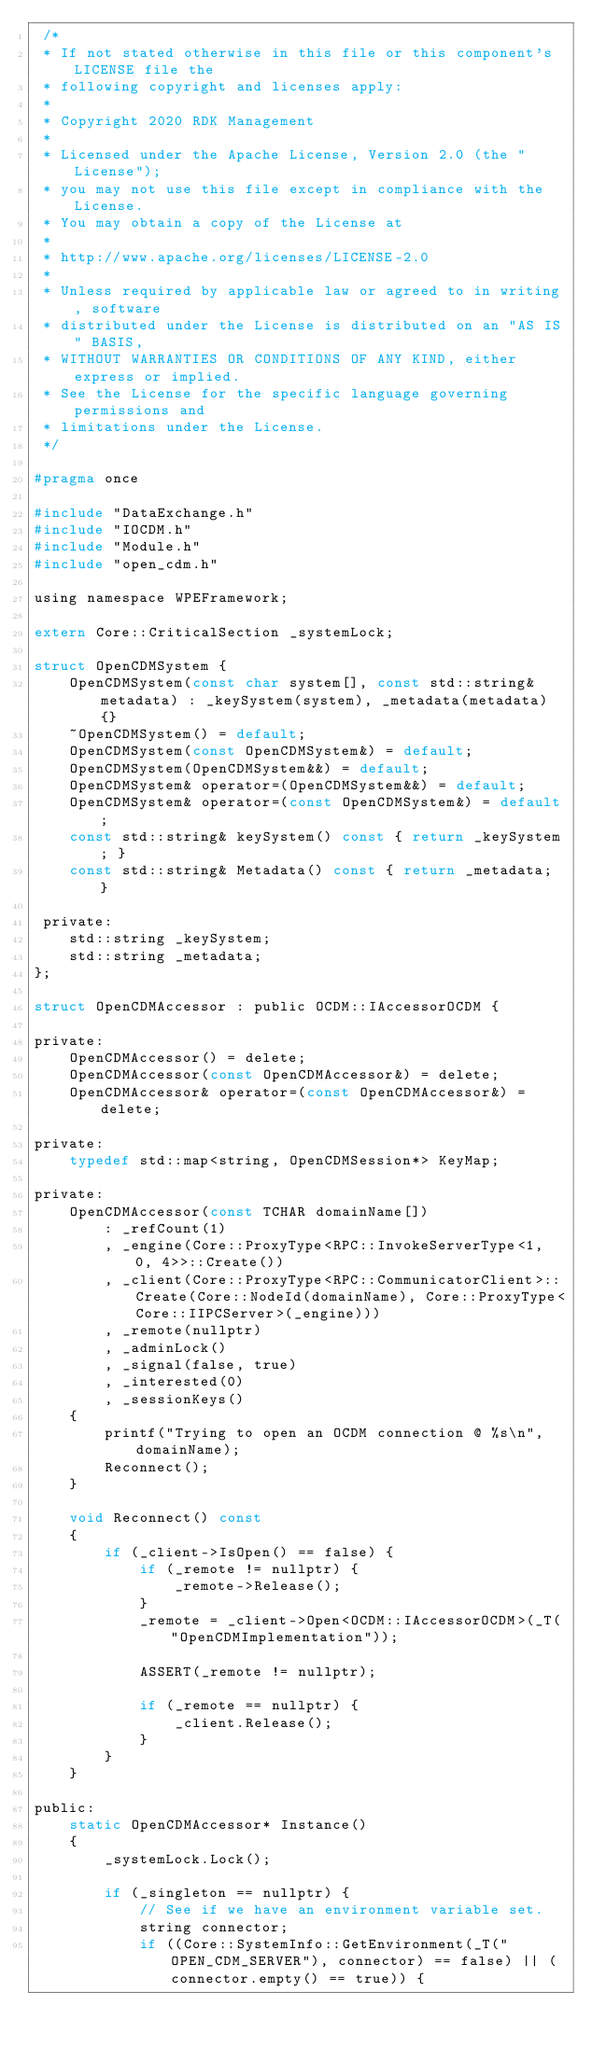<code> <loc_0><loc_0><loc_500><loc_500><_C_> /*
 * If not stated otherwise in this file or this component's LICENSE file the
 * following copyright and licenses apply:
 *
 * Copyright 2020 RDK Management
 *
 * Licensed under the Apache License, Version 2.0 (the "License");
 * you may not use this file except in compliance with the License.
 * You may obtain a copy of the License at
 *
 * http://www.apache.org/licenses/LICENSE-2.0
 *
 * Unless required by applicable law or agreed to in writing, software
 * distributed under the License is distributed on an "AS IS" BASIS,
 * WITHOUT WARRANTIES OR CONDITIONS OF ANY KIND, either express or implied.
 * See the License for the specific language governing permissions and
 * limitations under the License.
 */
 
#pragma once

#include "DataExchange.h"
#include "IOCDM.h"
#include "Module.h"
#include "open_cdm.h"

using namespace WPEFramework;

extern Core::CriticalSection _systemLock;

struct OpenCDMSystem {
    OpenCDMSystem(const char system[], const std::string& metadata) : _keySystem(system), _metadata(metadata) {}
    ~OpenCDMSystem() = default;
    OpenCDMSystem(const OpenCDMSystem&) = default;
    OpenCDMSystem(OpenCDMSystem&&) = default;
    OpenCDMSystem& operator=(OpenCDMSystem&&) = default;
    OpenCDMSystem& operator=(const OpenCDMSystem&) = default;
    const std::string& keySystem() const { return _keySystem; }
    const std::string& Metadata() const { return _metadata; }

 private:
    std::string _keySystem;
    std::string _metadata;
};

struct OpenCDMAccessor : public OCDM::IAccessorOCDM {

private:
    OpenCDMAccessor() = delete;
    OpenCDMAccessor(const OpenCDMAccessor&) = delete;
    OpenCDMAccessor& operator=(const OpenCDMAccessor&) = delete;

private:
    typedef std::map<string, OpenCDMSession*> KeyMap;

private:
    OpenCDMAccessor(const TCHAR domainName[])
        : _refCount(1)
        , _engine(Core::ProxyType<RPC::InvokeServerType<1, 0, 4>>::Create())
        , _client(Core::ProxyType<RPC::CommunicatorClient>::Create(Core::NodeId(domainName), Core::ProxyType<Core::IIPCServer>(_engine)))
        , _remote(nullptr)
        , _adminLock()
        , _signal(false, true)
        , _interested(0)
        , _sessionKeys()
    {
        printf("Trying to open an OCDM connection @ %s\n", domainName);
        Reconnect();
    }

    void Reconnect() const
    {
        if (_client->IsOpen() == false) {
            if (_remote != nullptr) {
                _remote->Release();
            }
            _remote = _client->Open<OCDM::IAccessorOCDM>(_T("OpenCDMImplementation"));

            ASSERT(_remote != nullptr);

            if (_remote == nullptr) {
                _client.Release();
            }
        }
    }

public:
    static OpenCDMAccessor* Instance()
    {
        _systemLock.Lock();

        if (_singleton == nullptr) {
            // See if we have an environment variable set.
            string connector;
            if ((Core::SystemInfo::GetEnvironment(_T("OPEN_CDM_SERVER"), connector) == false) || (connector.empty() == true)) {</code> 